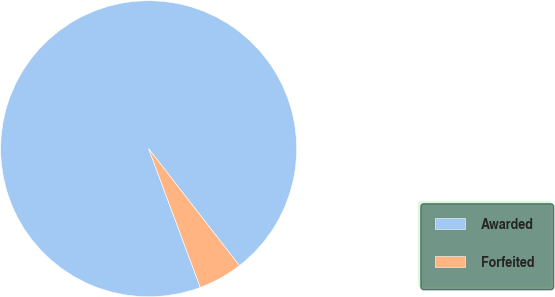Convert chart. <chart><loc_0><loc_0><loc_500><loc_500><pie_chart><fcel>Awarded<fcel>Forfeited<nl><fcel>95.17%<fcel>4.83%<nl></chart> 